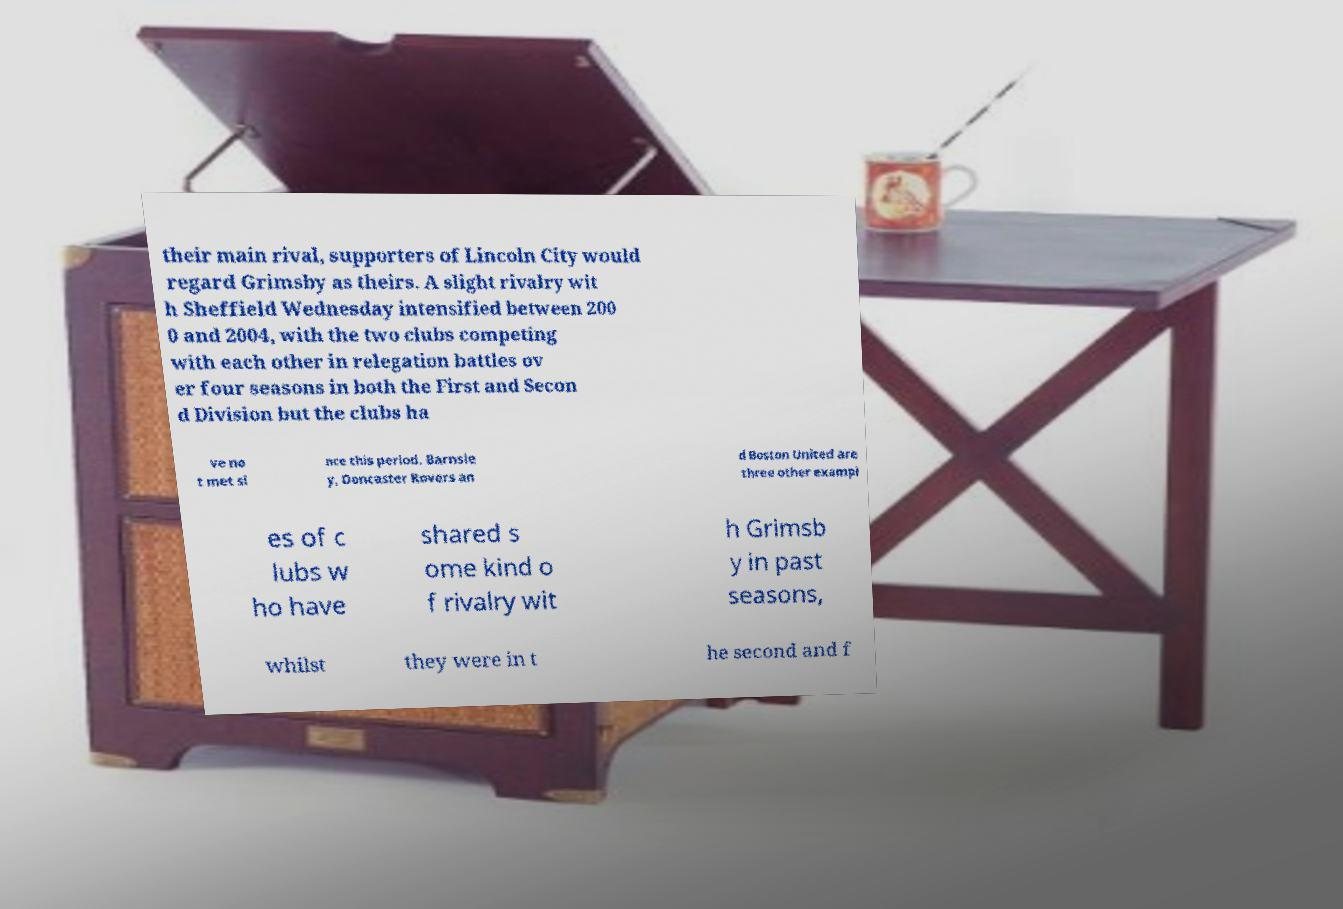Could you assist in decoding the text presented in this image and type it out clearly? their main rival, supporters of Lincoln City would regard Grimsby as theirs. A slight rivalry wit h Sheffield Wednesday intensified between 200 0 and 2004, with the two clubs competing with each other in relegation battles ov er four seasons in both the First and Secon d Division but the clubs ha ve no t met si nce this period. Barnsle y, Doncaster Rovers an d Boston United are three other exampl es of c lubs w ho have shared s ome kind o f rivalry wit h Grimsb y in past seasons, whilst they were in t he second and f 